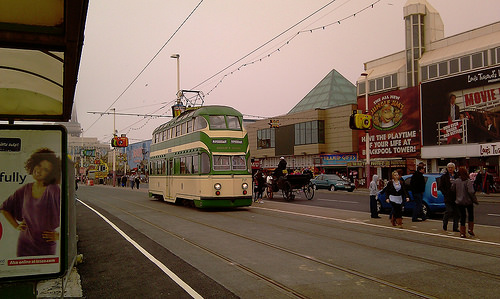<image>
Is the horse in the bus? No. The horse is not contained within the bus. These objects have a different spatial relationship. Is there a electric wire in front of the building? Yes. The electric wire is positioned in front of the building, appearing closer to the camera viewpoint. 